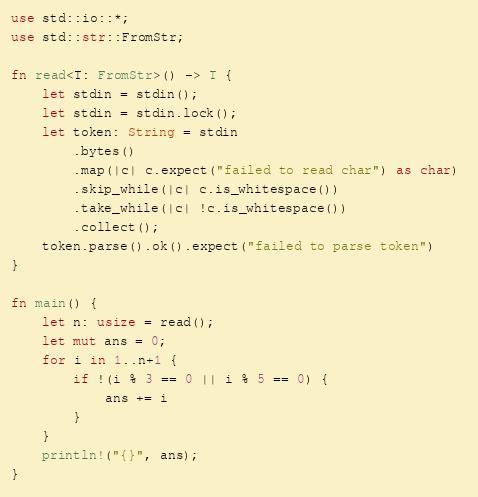<code> <loc_0><loc_0><loc_500><loc_500><_Rust_>use std::io::*;
use std::str::FromStr;

fn read<T: FromStr>() -> T {
    let stdin = stdin();
    let stdin = stdin.lock();
    let token: String = stdin
        .bytes()
        .map(|c| c.expect("failed to read char") as char) 
        .skip_while(|c| c.is_whitespace())
        .take_while(|c| !c.is_whitespace())
        .collect();
    token.parse().ok().expect("failed to parse token")
}

fn main() {
    let n: usize = read();
    let mut ans = 0;
    for i in 1..n+1 {
        if !(i % 3 == 0 || i % 5 == 0) {
            ans += i
        }
    }
    println!("{}", ans);
}
</code> 